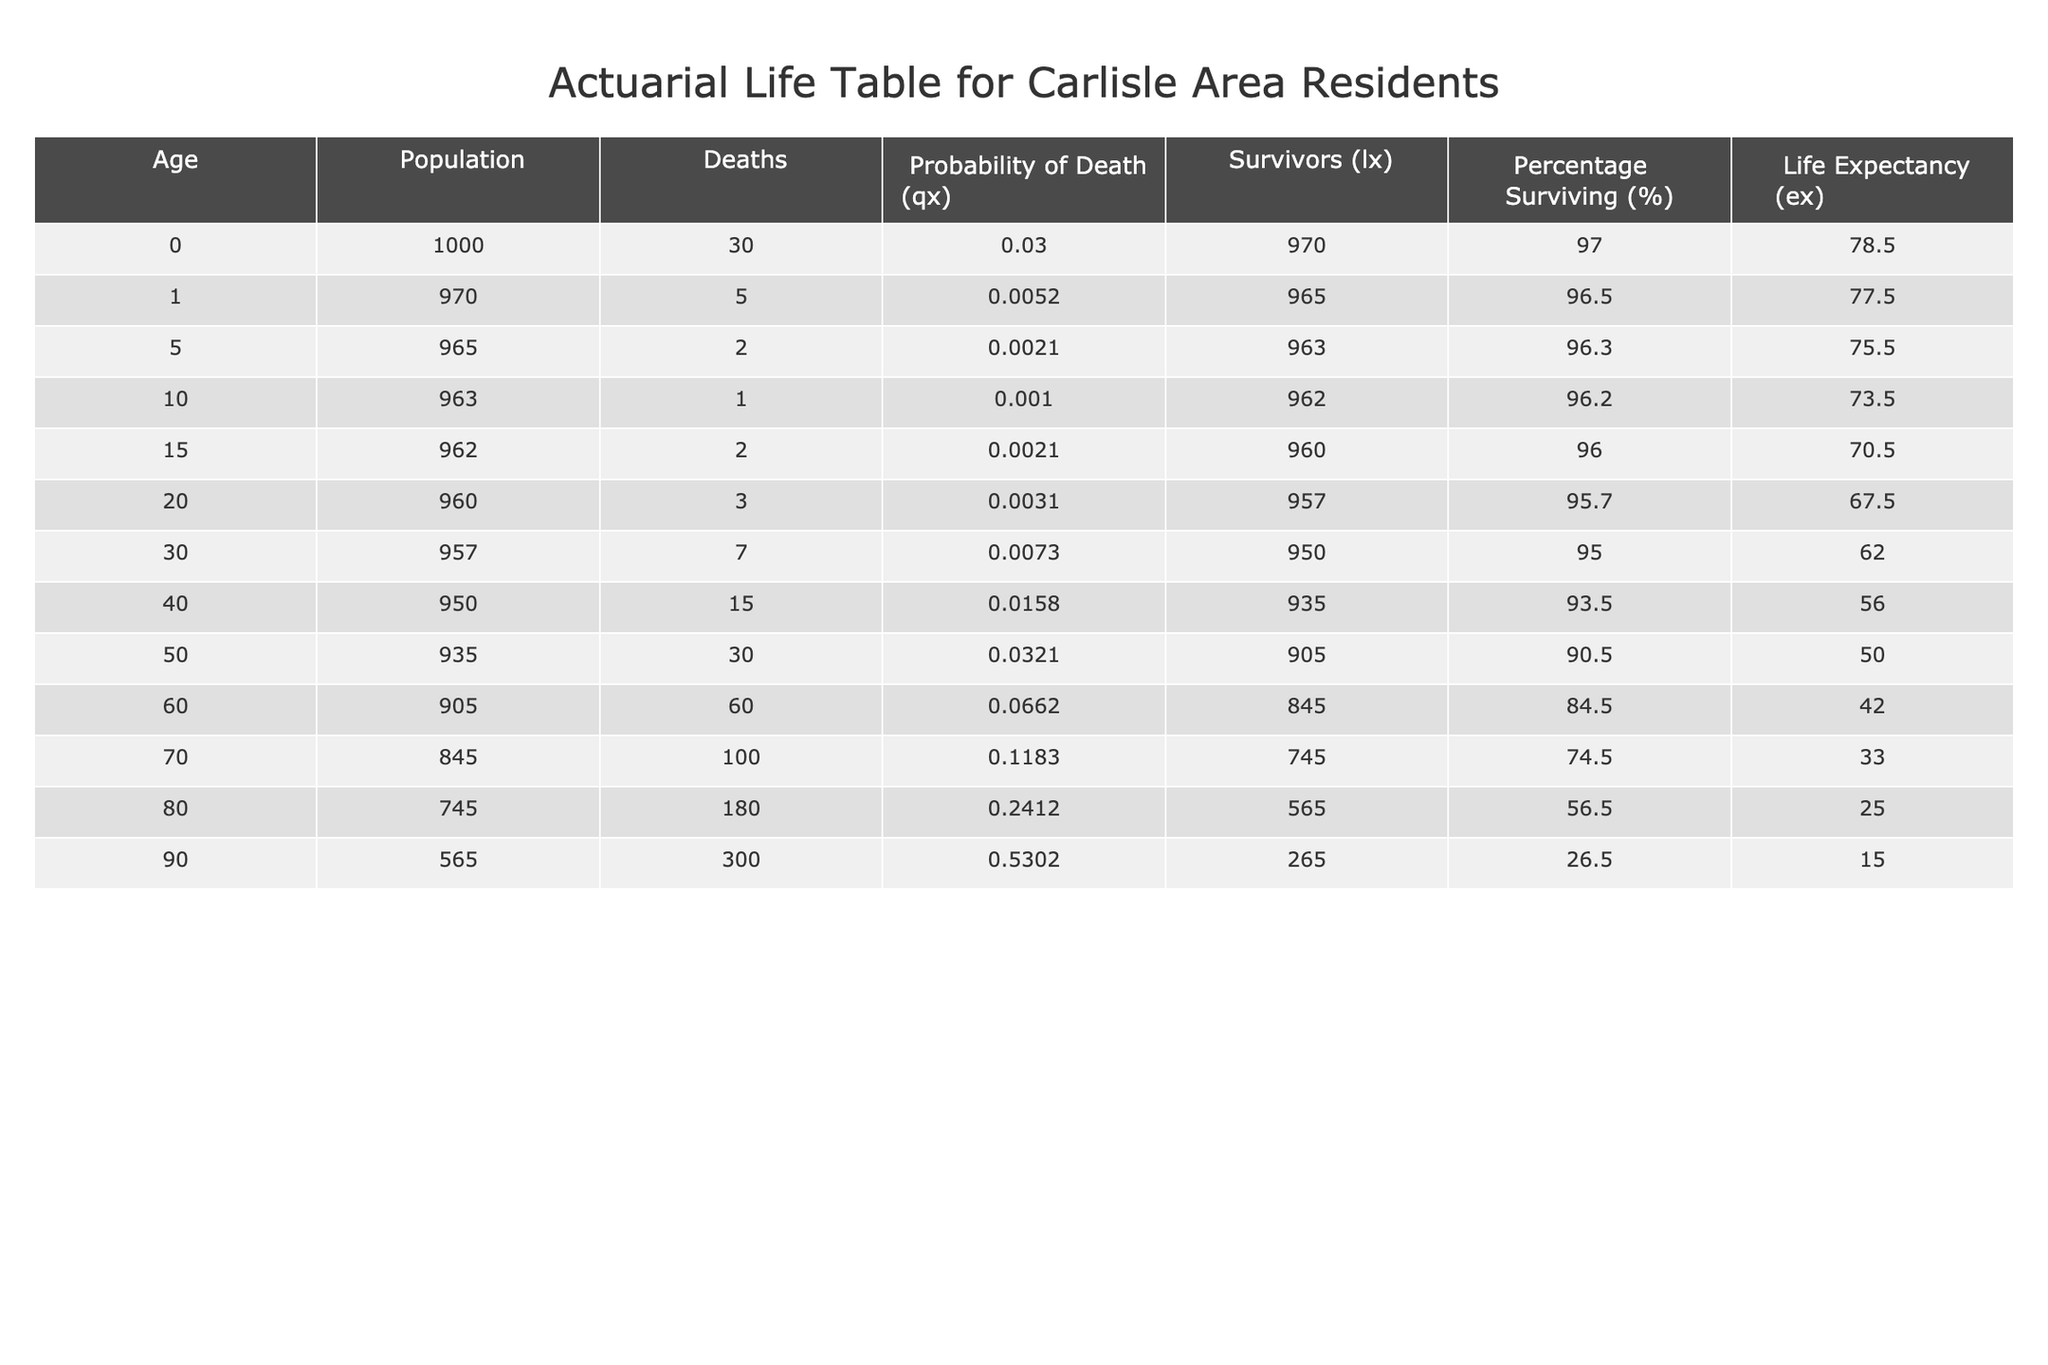What is the life expectancy at age 70? The life expectancy at age 70 is given directly in the table under the "Life Expectancy (ex)" column for the corresponding row. For age 70, the value is 33.0.
Answer: 33.0 How many residents survive to age 50? The number of survivors to age 50 is noted in the "Survivors (lx)" column for the age 50 row. It shows that 905 residents make it to age 50.
Answer: 905 What is the probability of dying between ages 80 and 90? To find the probability of dying between ages 80 and 90, we look at the "Probability of Death (qx)" values for age 80 and age 90. For age 80, it is 0.2412, and for age 90, it is 0.5302. The probability of dying between these ages is the difference of these two probabilities: 0.5302 - 0.2412 = 0.2890.
Answer: 0.2890 Is the percentage of survivors at age 60 greater than at age 80? For this question, we compare the "Percentage Surviving (%)" values for ages 60 and 80. For age 60, the percentage is 84.5%, while for age 80, it is 56.5%. Since 84.5% is greater than 56.5%, the answer is yes.
Answer: Yes What is the average life expectancy for those who survive to age 40? To calculate the average life expectancy for residents who reach age 40, we take the "Life Expectancy (ex)" values for all subsequent ages from 40 onward (40, 50, 60, 70, 80, 90). The values are 56.0, 50.0, 42.0, 33.0, 25.0, and 15.0. The sum of these values is 56.0 + 50.0 + 42.0 + 33.0 + 25.0 + 15.0 = 221. We then divide by the number of data points (6): 221 / 6 = 36.83.
Answer: 36.83 